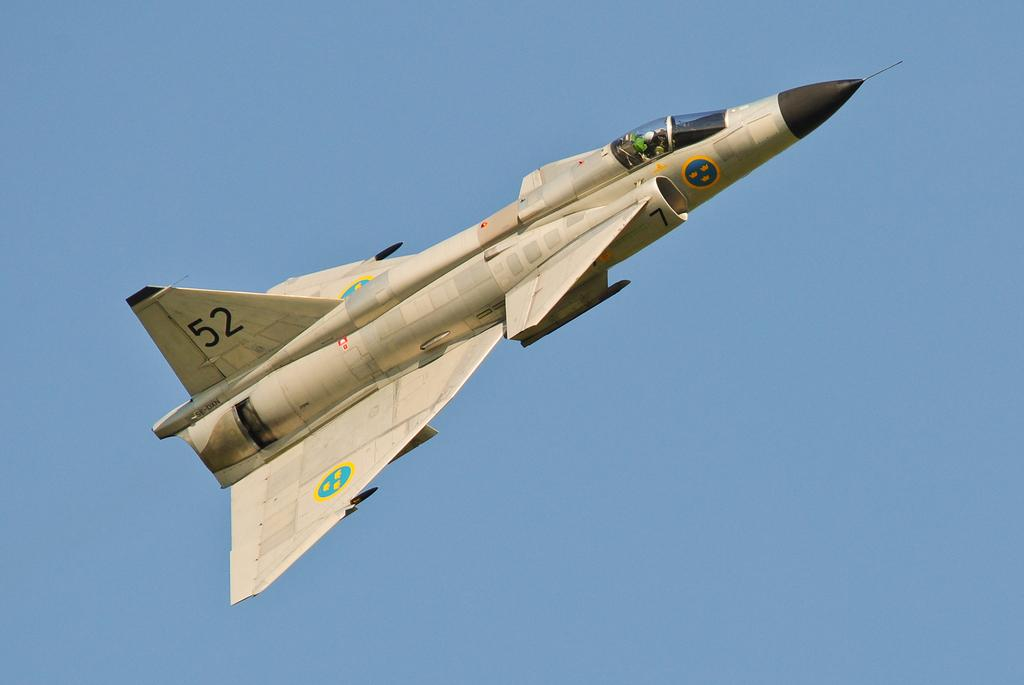What is the main subject of the image? The main subject of the image is a jet plane. What is the jet plane doing in the image? The jet plane is flying in the sky. In which direction is the jet plane flying? The jet plane is flying towards the right. Is there anyone on the jet plane? Yes, there is a person riding the jet plane. What can be seen in the background of the image? The sky is visible in the background of the image. What type of zephyr can be seen in the image? There is no zephyr present in the image; it is a jet plane flying in the sky. What flavor of eggnog is being served on the jet plane? There is no eggnog present in the image; it is a jet plane flying in the sky with a person on board. 